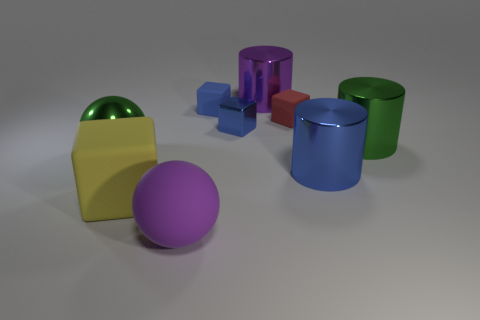Add 1 shiny things. How many objects exist? 10 Subtract all cylinders. How many objects are left? 6 Add 4 metal cubes. How many metal cubes exist? 5 Subtract 1 purple balls. How many objects are left? 8 Subtract all big red objects. Subtract all small objects. How many objects are left? 6 Add 8 yellow things. How many yellow things are left? 9 